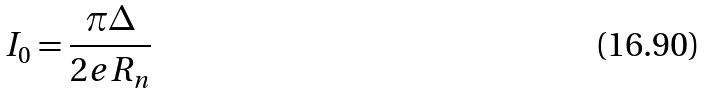Convert formula to latex. <formula><loc_0><loc_0><loc_500><loc_500>I _ { 0 } = \frac { \pi \Delta } { 2 e R _ { n } }</formula> 